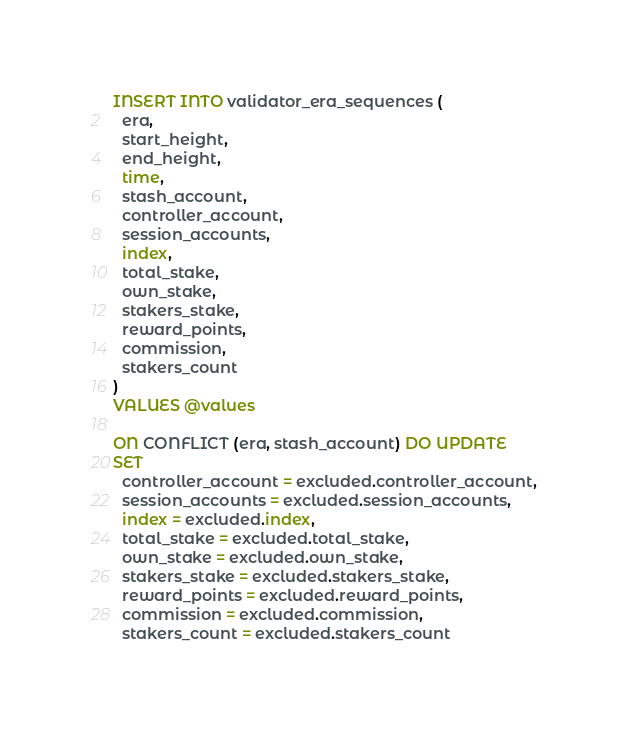Convert code to text. <code><loc_0><loc_0><loc_500><loc_500><_SQL_>INSERT INTO validator_era_sequences (
  era,
  start_height,
  end_height,
  time,
  stash_account,
  controller_account,
  session_accounts,
  index,
  total_stake,
  own_stake,
  stakers_stake,
  reward_points,
  commission,
  stakers_count
)
VALUES @values

ON CONFLICT (era, stash_account) DO UPDATE
SET
  controller_account = excluded.controller_account,
  session_accounts = excluded.session_accounts,
  index = excluded.index,
  total_stake = excluded.total_stake,
  own_stake = excluded.own_stake,
  stakers_stake = excluded.stakers_stake,
  reward_points = excluded.reward_points,
  commission = excluded.commission,
  stakers_count = excluded.stakers_count
</code> 